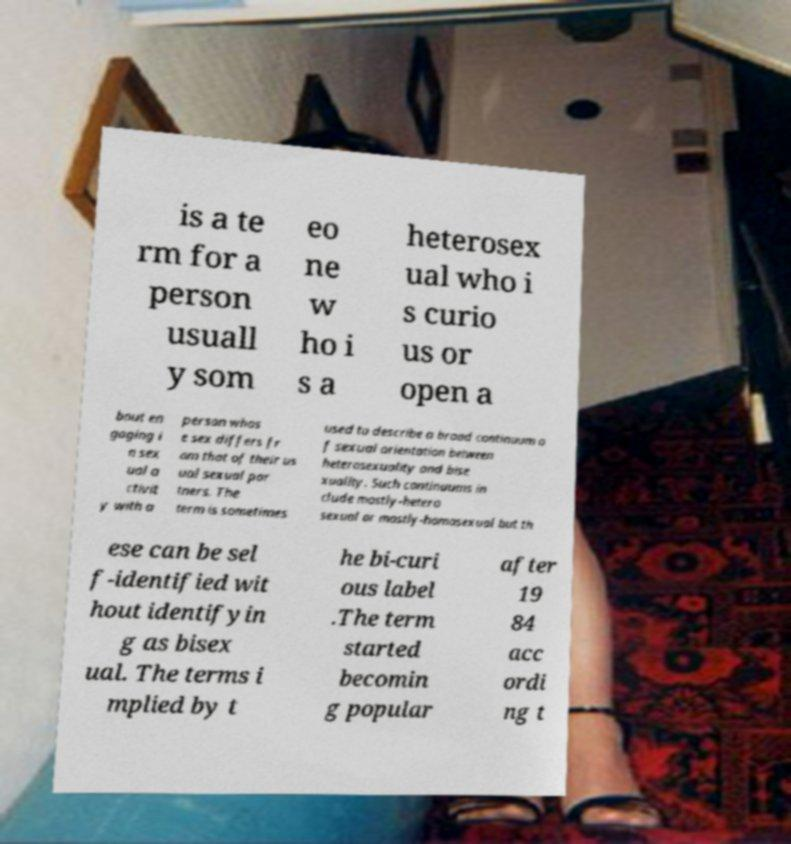What messages or text are displayed in this image? I need them in a readable, typed format. is a te rm for a person usuall y som eo ne w ho i s a heterosex ual who i s curio us or open a bout en gaging i n sex ual a ctivit y with a person whos e sex differs fr om that of their us ual sexual par tners. The term is sometimes used to describe a broad continuum o f sexual orientation between heterosexuality and bise xuality. Such continuums in clude mostly-hetero sexual or mostly-homosexual but th ese can be sel f-identified wit hout identifyin g as bisex ual. The terms i mplied by t he bi-curi ous label .The term started becomin g popular after 19 84 acc ordi ng t 